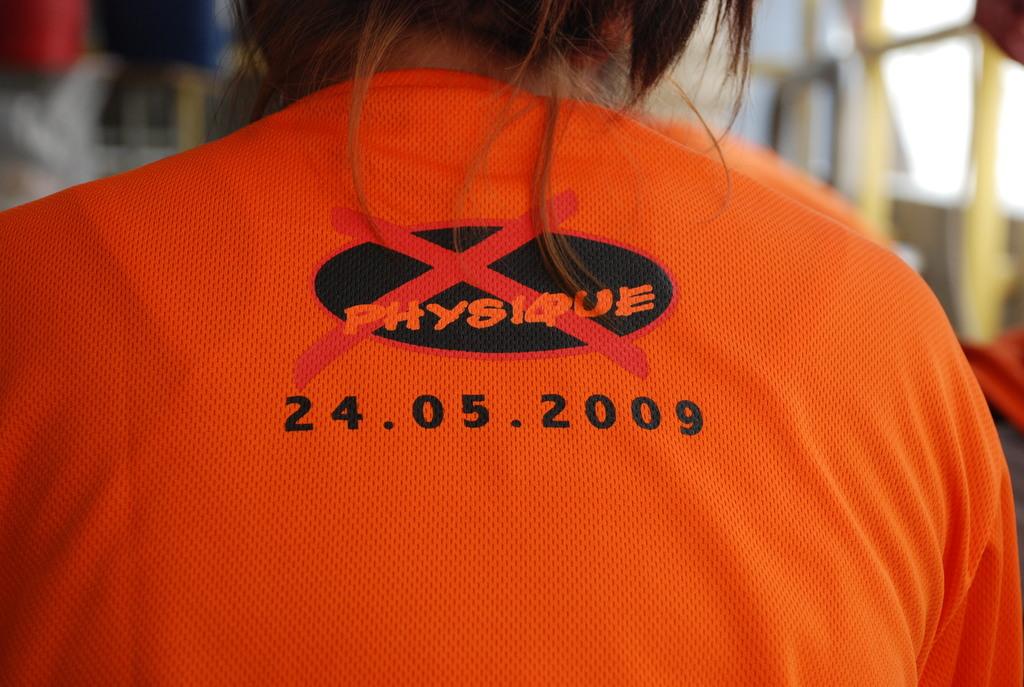What is the year printed on the back of the shirt?
Provide a short and direct response. 2009. What is the name above the date?
Ensure brevity in your answer.  Physique. 